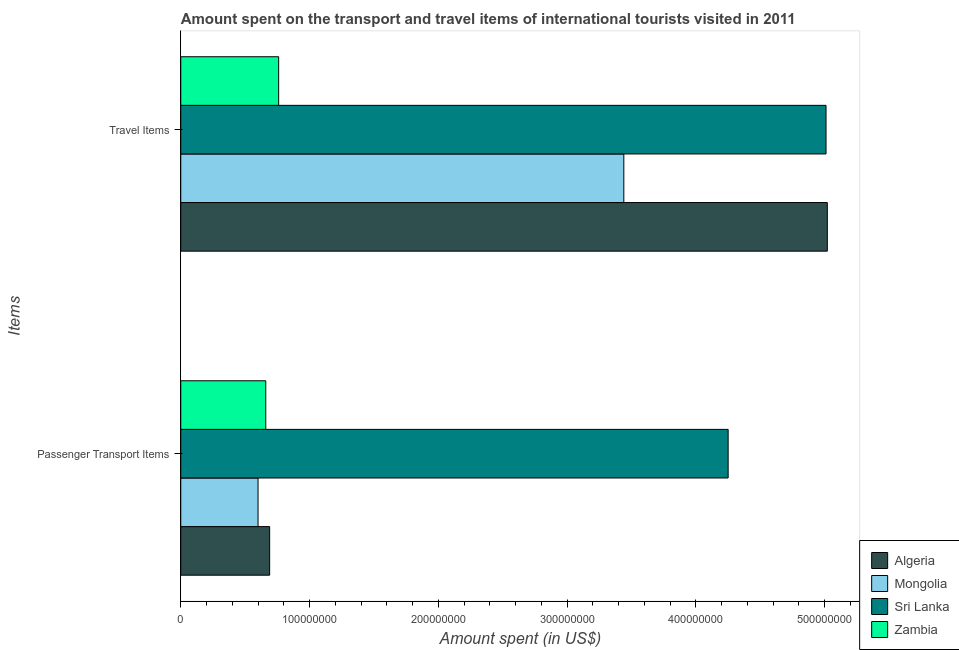How many different coloured bars are there?
Your answer should be very brief. 4. How many groups of bars are there?
Provide a succinct answer. 2. Are the number of bars per tick equal to the number of legend labels?
Keep it short and to the point. Yes. How many bars are there on the 1st tick from the top?
Your answer should be compact. 4. How many bars are there on the 1st tick from the bottom?
Give a very brief answer. 4. What is the label of the 2nd group of bars from the top?
Provide a succinct answer. Passenger Transport Items. What is the amount spent in travel items in Zambia?
Your answer should be very brief. 7.60e+07. Across all countries, what is the maximum amount spent on passenger transport items?
Ensure brevity in your answer.  4.25e+08. Across all countries, what is the minimum amount spent in travel items?
Keep it short and to the point. 7.60e+07. In which country was the amount spent on passenger transport items maximum?
Your response must be concise. Sri Lanka. In which country was the amount spent in travel items minimum?
Your response must be concise. Zambia. What is the total amount spent on passenger transport items in the graph?
Provide a short and direct response. 6.20e+08. What is the difference between the amount spent in travel items in Zambia and that in Algeria?
Provide a succinct answer. -4.26e+08. What is the difference between the amount spent in travel items in Zambia and the amount spent on passenger transport items in Mongolia?
Provide a succinct answer. 1.60e+07. What is the average amount spent in travel items per country?
Your answer should be compact. 3.56e+08. What is the difference between the amount spent on passenger transport items and amount spent in travel items in Sri Lanka?
Your answer should be very brief. -7.60e+07. In how many countries, is the amount spent in travel items greater than 220000000 US$?
Your response must be concise. 3. What is the ratio of the amount spent in travel items in Algeria to that in Sri Lanka?
Give a very brief answer. 1. In how many countries, is the amount spent on passenger transport items greater than the average amount spent on passenger transport items taken over all countries?
Offer a very short reply. 1. What does the 1st bar from the top in Travel Items represents?
Make the answer very short. Zambia. What does the 4th bar from the bottom in Travel Items represents?
Keep it short and to the point. Zambia. How many countries are there in the graph?
Your response must be concise. 4. What is the difference between two consecutive major ticks on the X-axis?
Your answer should be very brief. 1.00e+08. Are the values on the major ticks of X-axis written in scientific E-notation?
Offer a very short reply. No. Does the graph contain any zero values?
Ensure brevity in your answer.  No. Does the graph contain grids?
Give a very brief answer. No. Where does the legend appear in the graph?
Your answer should be compact. Bottom right. How many legend labels are there?
Make the answer very short. 4. How are the legend labels stacked?
Your answer should be very brief. Vertical. What is the title of the graph?
Offer a very short reply. Amount spent on the transport and travel items of international tourists visited in 2011. Does "Micronesia" appear as one of the legend labels in the graph?
Offer a very short reply. No. What is the label or title of the X-axis?
Your response must be concise. Amount spent (in US$). What is the label or title of the Y-axis?
Ensure brevity in your answer.  Items. What is the Amount spent (in US$) of Algeria in Passenger Transport Items?
Your response must be concise. 6.90e+07. What is the Amount spent (in US$) of Mongolia in Passenger Transport Items?
Give a very brief answer. 6.00e+07. What is the Amount spent (in US$) of Sri Lanka in Passenger Transport Items?
Make the answer very short. 4.25e+08. What is the Amount spent (in US$) of Zambia in Passenger Transport Items?
Keep it short and to the point. 6.60e+07. What is the Amount spent (in US$) of Algeria in Travel Items?
Offer a very short reply. 5.02e+08. What is the Amount spent (in US$) of Mongolia in Travel Items?
Provide a succinct answer. 3.44e+08. What is the Amount spent (in US$) of Sri Lanka in Travel Items?
Your response must be concise. 5.01e+08. What is the Amount spent (in US$) of Zambia in Travel Items?
Give a very brief answer. 7.60e+07. Across all Items, what is the maximum Amount spent (in US$) in Algeria?
Keep it short and to the point. 5.02e+08. Across all Items, what is the maximum Amount spent (in US$) in Mongolia?
Your answer should be compact. 3.44e+08. Across all Items, what is the maximum Amount spent (in US$) in Sri Lanka?
Make the answer very short. 5.01e+08. Across all Items, what is the maximum Amount spent (in US$) in Zambia?
Provide a succinct answer. 7.60e+07. Across all Items, what is the minimum Amount spent (in US$) of Algeria?
Your answer should be compact. 6.90e+07. Across all Items, what is the minimum Amount spent (in US$) in Mongolia?
Make the answer very short. 6.00e+07. Across all Items, what is the minimum Amount spent (in US$) of Sri Lanka?
Offer a very short reply. 4.25e+08. Across all Items, what is the minimum Amount spent (in US$) of Zambia?
Keep it short and to the point. 6.60e+07. What is the total Amount spent (in US$) of Algeria in the graph?
Give a very brief answer. 5.71e+08. What is the total Amount spent (in US$) in Mongolia in the graph?
Your response must be concise. 4.04e+08. What is the total Amount spent (in US$) of Sri Lanka in the graph?
Your answer should be very brief. 9.26e+08. What is the total Amount spent (in US$) in Zambia in the graph?
Ensure brevity in your answer.  1.42e+08. What is the difference between the Amount spent (in US$) in Algeria in Passenger Transport Items and that in Travel Items?
Give a very brief answer. -4.33e+08. What is the difference between the Amount spent (in US$) of Mongolia in Passenger Transport Items and that in Travel Items?
Make the answer very short. -2.84e+08. What is the difference between the Amount spent (in US$) in Sri Lanka in Passenger Transport Items and that in Travel Items?
Provide a short and direct response. -7.60e+07. What is the difference between the Amount spent (in US$) of Zambia in Passenger Transport Items and that in Travel Items?
Give a very brief answer. -1.00e+07. What is the difference between the Amount spent (in US$) in Algeria in Passenger Transport Items and the Amount spent (in US$) in Mongolia in Travel Items?
Offer a terse response. -2.75e+08. What is the difference between the Amount spent (in US$) in Algeria in Passenger Transport Items and the Amount spent (in US$) in Sri Lanka in Travel Items?
Ensure brevity in your answer.  -4.32e+08. What is the difference between the Amount spent (in US$) in Algeria in Passenger Transport Items and the Amount spent (in US$) in Zambia in Travel Items?
Offer a terse response. -7.00e+06. What is the difference between the Amount spent (in US$) in Mongolia in Passenger Transport Items and the Amount spent (in US$) in Sri Lanka in Travel Items?
Offer a very short reply. -4.41e+08. What is the difference between the Amount spent (in US$) in Mongolia in Passenger Transport Items and the Amount spent (in US$) in Zambia in Travel Items?
Make the answer very short. -1.60e+07. What is the difference between the Amount spent (in US$) in Sri Lanka in Passenger Transport Items and the Amount spent (in US$) in Zambia in Travel Items?
Provide a succinct answer. 3.49e+08. What is the average Amount spent (in US$) of Algeria per Items?
Provide a short and direct response. 2.86e+08. What is the average Amount spent (in US$) of Mongolia per Items?
Ensure brevity in your answer.  2.02e+08. What is the average Amount spent (in US$) of Sri Lanka per Items?
Keep it short and to the point. 4.63e+08. What is the average Amount spent (in US$) of Zambia per Items?
Give a very brief answer. 7.10e+07. What is the difference between the Amount spent (in US$) of Algeria and Amount spent (in US$) of Mongolia in Passenger Transport Items?
Ensure brevity in your answer.  9.00e+06. What is the difference between the Amount spent (in US$) in Algeria and Amount spent (in US$) in Sri Lanka in Passenger Transport Items?
Your response must be concise. -3.56e+08. What is the difference between the Amount spent (in US$) in Mongolia and Amount spent (in US$) in Sri Lanka in Passenger Transport Items?
Provide a succinct answer. -3.65e+08. What is the difference between the Amount spent (in US$) of Mongolia and Amount spent (in US$) of Zambia in Passenger Transport Items?
Your answer should be compact. -6.00e+06. What is the difference between the Amount spent (in US$) of Sri Lanka and Amount spent (in US$) of Zambia in Passenger Transport Items?
Your answer should be compact. 3.59e+08. What is the difference between the Amount spent (in US$) in Algeria and Amount spent (in US$) in Mongolia in Travel Items?
Provide a succinct answer. 1.58e+08. What is the difference between the Amount spent (in US$) in Algeria and Amount spent (in US$) in Zambia in Travel Items?
Your response must be concise. 4.26e+08. What is the difference between the Amount spent (in US$) of Mongolia and Amount spent (in US$) of Sri Lanka in Travel Items?
Your answer should be very brief. -1.57e+08. What is the difference between the Amount spent (in US$) in Mongolia and Amount spent (in US$) in Zambia in Travel Items?
Provide a short and direct response. 2.68e+08. What is the difference between the Amount spent (in US$) in Sri Lanka and Amount spent (in US$) in Zambia in Travel Items?
Your answer should be compact. 4.25e+08. What is the ratio of the Amount spent (in US$) in Algeria in Passenger Transport Items to that in Travel Items?
Offer a terse response. 0.14. What is the ratio of the Amount spent (in US$) in Mongolia in Passenger Transport Items to that in Travel Items?
Keep it short and to the point. 0.17. What is the ratio of the Amount spent (in US$) in Sri Lanka in Passenger Transport Items to that in Travel Items?
Give a very brief answer. 0.85. What is the ratio of the Amount spent (in US$) of Zambia in Passenger Transport Items to that in Travel Items?
Your answer should be very brief. 0.87. What is the difference between the highest and the second highest Amount spent (in US$) of Algeria?
Provide a succinct answer. 4.33e+08. What is the difference between the highest and the second highest Amount spent (in US$) in Mongolia?
Provide a succinct answer. 2.84e+08. What is the difference between the highest and the second highest Amount spent (in US$) of Sri Lanka?
Offer a terse response. 7.60e+07. What is the difference between the highest and the second highest Amount spent (in US$) of Zambia?
Your answer should be compact. 1.00e+07. What is the difference between the highest and the lowest Amount spent (in US$) in Algeria?
Provide a succinct answer. 4.33e+08. What is the difference between the highest and the lowest Amount spent (in US$) of Mongolia?
Your answer should be very brief. 2.84e+08. What is the difference between the highest and the lowest Amount spent (in US$) of Sri Lanka?
Provide a short and direct response. 7.60e+07. What is the difference between the highest and the lowest Amount spent (in US$) in Zambia?
Provide a succinct answer. 1.00e+07. 